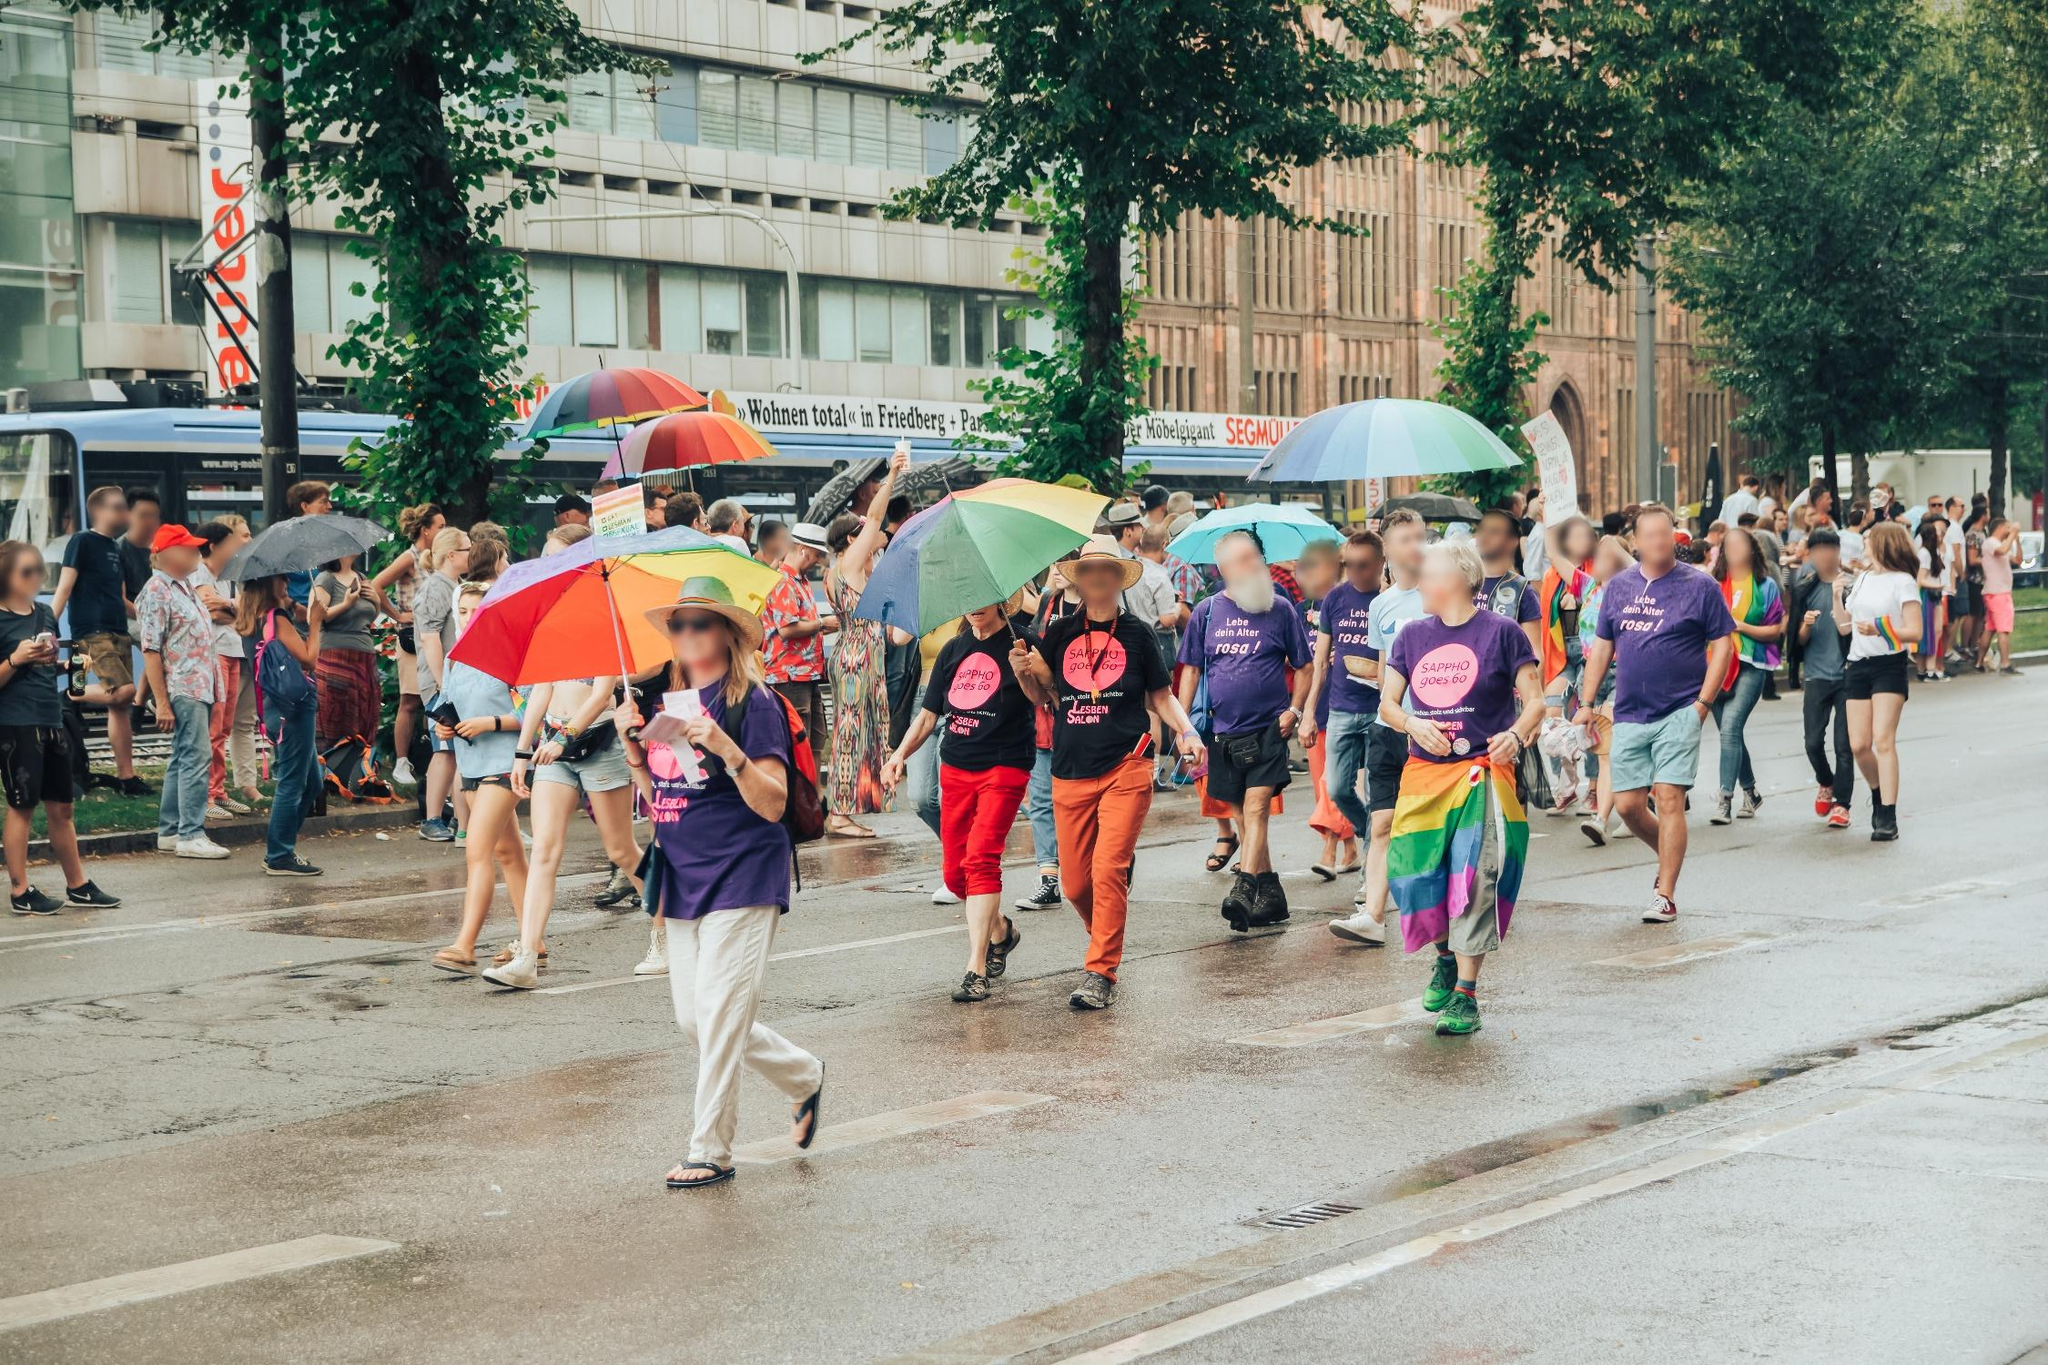What kind of event do you think is being represented in this image and why? The scene appears to be a pride parade celebrating LGBTQ+ rights and diversity. This inference is based on the numerous rainbow-colored umbrellas and accessories, as well as the slogans on t-shirts, which are commonly associated with pride events. The overall festive and inclusive atmosphere also supports this interpretation. Can you describe more about the people and their outfits? The participants are dressed in a variety of colorful clothes, with many wearing t-shirts sporting slogans supportive of LGBTQ+ communities. Some people carry rainbow flags, and others have accessorized with hats and scarves in bright colors. The blend of casual wear and more festive attire creates an atmosphere of joyous celebration and solidarity. Imagine you are one of the people in the parade. Describe your experience. As a participant in this vibrant parade, I am filled with a sense of pride and community. The sea of colorful umbrellas and attire around me creates a visual spectacle that is exhilarating to be part of. The cheering crowd and the supportive chants make me feel accepted and valued. Walking down the street, I engage with fellow marchers and spectators, sharing smiles, high-fives, and words of encouragement. The experience is both emotionally uplifting and empowering, as I march in solidarity with countless others advocating for equality and celebrating diversity. 